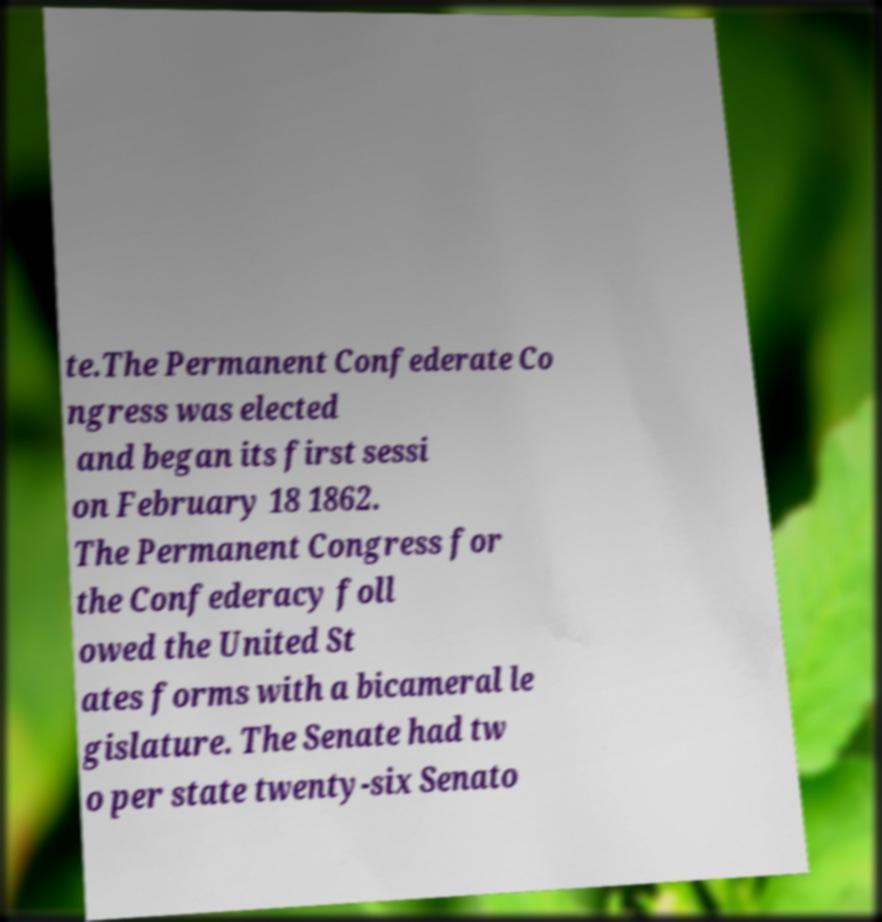There's text embedded in this image that I need extracted. Can you transcribe it verbatim? te.The Permanent Confederate Co ngress was elected and began its first sessi on February 18 1862. The Permanent Congress for the Confederacy foll owed the United St ates forms with a bicameral le gislature. The Senate had tw o per state twenty-six Senato 